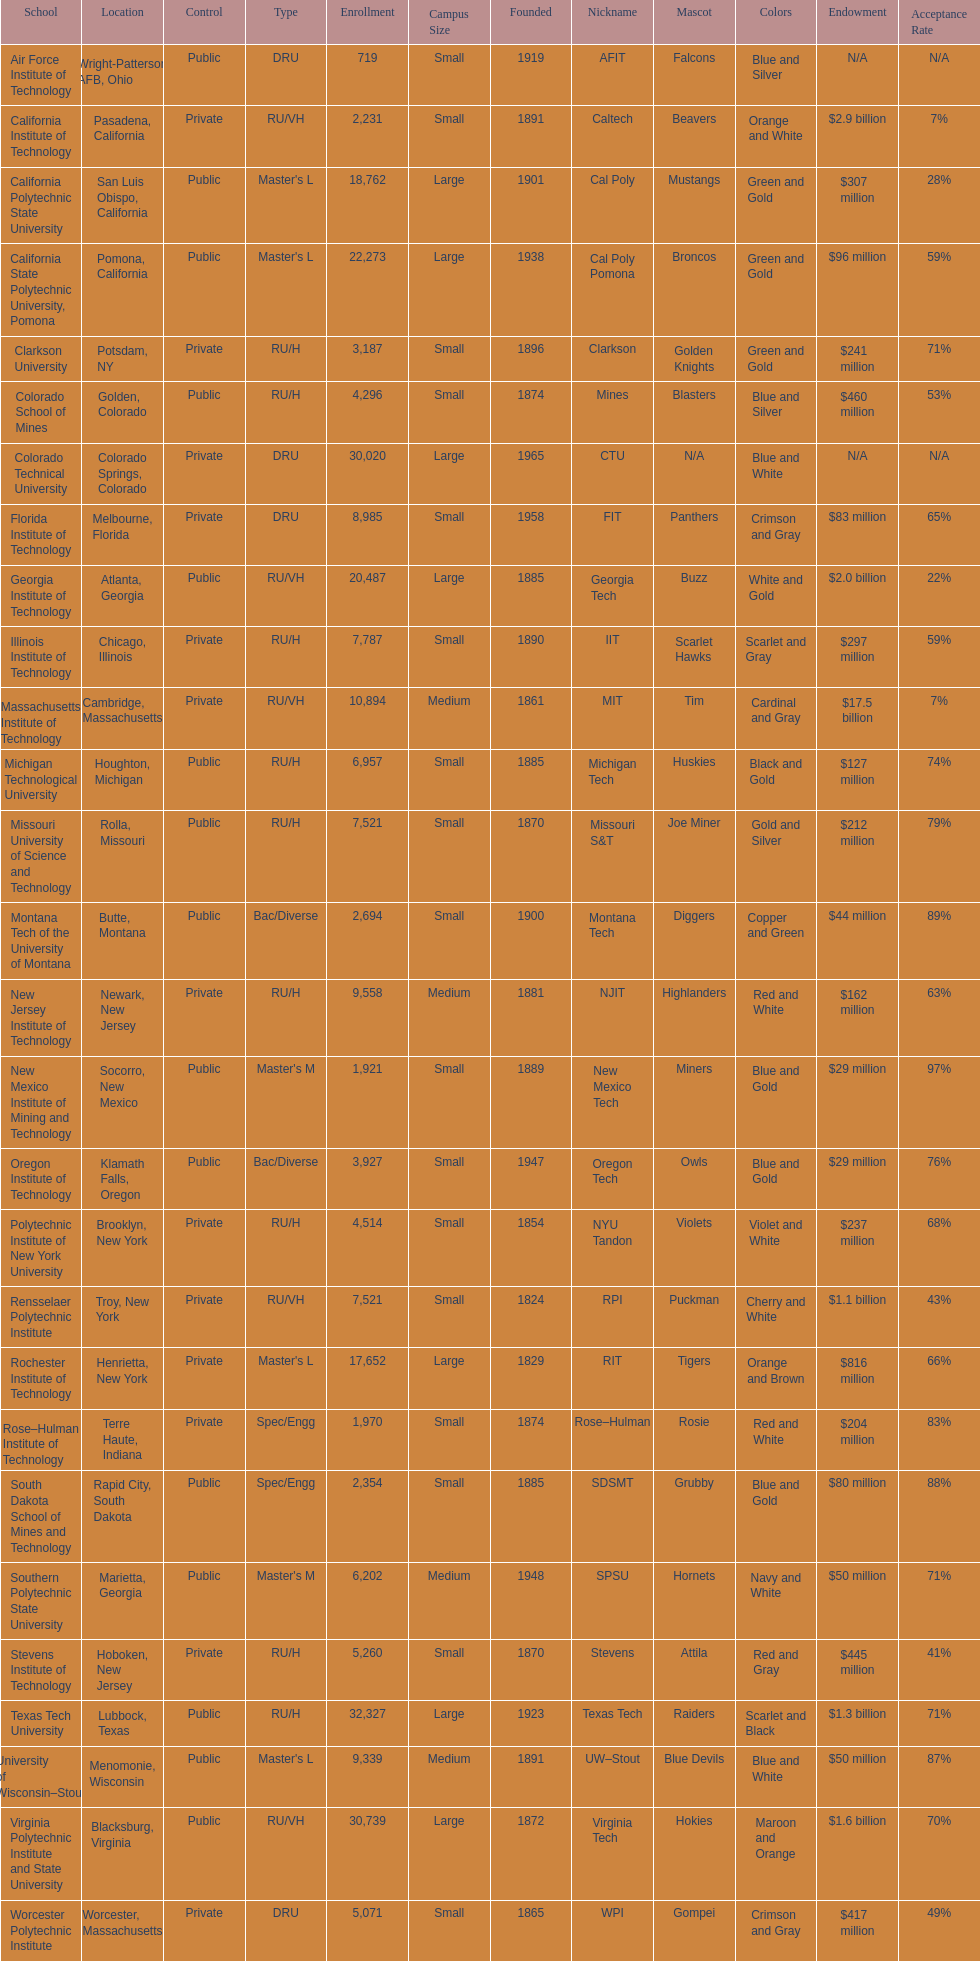Parse the full table. {'header': ['School', 'Location', 'Control', 'Type', 'Enrollment', 'Campus Size', 'Founded', 'Nickname', 'Mascot', 'Colors', 'Endowment', 'Acceptance Rate'], 'rows': [['Air Force Institute of Technology', 'Wright-Patterson AFB, Ohio', 'Public', 'DRU', '719', 'Small', '1919', 'AFIT', 'Falcons', 'Blue and Silver', 'N/A', 'N/A'], ['California Institute of Technology', 'Pasadena, California', 'Private', 'RU/VH', '2,231', 'Small', '1891', 'Caltech', 'Beavers', 'Orange and White', '$2.9 billion', '7%'], ['California Polytechnic State University', 'San Luis Obispo, California', 'Public', "Master's L", '18,762', 'Large', '1901', 'Cal Poly', 'Mustangs', 'Green and Gold', '$307 million', '28%'], ['California State Polytechnic University, Pomona', 'Pomona, California', 'Public', "Master's L", '22,273', 'Large', '1938', 'Cal Poly Pomona', 'Broncos', 'Green and Gold', '$96 million', '59%'], ['Clarkson University', 'Potsdam, NY', 'Private', 'RU/H', '3,187', 'Small', '1896', 'Clarkson', 'Golden Knights', 'Green and Gold', '$241 million', '71%'], ['Colorado School of Mines', 'Golden, Colorado', 'Public', 'RU/H', '4,296', 'Small', '1874', 'Mines', 'Blasters', 'Blue and Silver', '$460 million', '53%'], ['Colorado Technical University', 'Colorado Springs, Colorado', 'Private', 'DRU', '30,020', 'Large', '1965', 'CTU', 'N/A', 'Blue and White', 'N/A', 'N/A'], ['Florida Institute of Technology', 'Melbourne, Florida', 'Private', 'DRU', '8,985', 'Small', '1958', 'FIT', 'Panthers', 'Crimson and Gray', '$83 million', '65%'], ['Georgia Institute of Technology', 'Atlanta, Georgia', 'Public', 'RU/VH', '20,487', 'Large', '1885', 'Georgia Tech', 'Buzz', 'White and Gold', '$2.0 billion', '22%'], ['Illinois Institute of Technology', 'Chicago, Illinois', 'Private', 'RU/H', '7,787', 'Small', '1890', 'IIT', 'Scarlet Hawks', 'Scarlet and Gray', '$297 million', '59%'], ['Massachusetts Institute of Technology', 'Cambridge, Massachusetts', 'Private', 'RU/VH', '10,894', 'Medium', '1861', 'MIT', 'Tim', 'Cardinal and Gray', '$17.5 billion', '7%'], ['Michigan Technological University', 'Houghton, Michigan', 'Public', 'RU/H', '6,957', 'Small', '1885', 'Michigan Tech', 'Huskies', 'Black and Gold', '$127 million', '74%'], ['Missouri University of Science and Technology', 'Rolla, Missouri', 'Public', 'RU/H', '7,521', 'Small', '1870', 'Missouri S&T', 'Joe Miner', 'Gold and Silver', '$212 million', '79%'], ['Montana Tech of the University of Montana', 'Butte, Montana', 'Public', 'Bac/Diverse', '2,694', 'Small', '1900', 'Montana Tech', 'Diggers', 'Copper and Green', '$44 million', '89%'], ['New Jersey Institute of Technology', 'Newark, New Jersey', 'Private', 'RU/H', '9,558', 'Medium', '1881', 'NJIT', 'Highlanders', 'Red and White', '$162 million', '63%'], ['New Mexico Institute of Mining and Technology', 'Socorro, New Mexico', 'Public', "Master's M", '1,921', 'Small', '1889', 'New Mexico Tech', 'Miners', 'Blue and Gold', '$29 million', '97%'], ['Oregon Institute of Technology', 'Klamath Falls, Oregon', 'Public', 'Bac/Diverse', '3,927', 'Small', '1947', 'Oregon Tech', 'Owls', 'Blue and Gold', '$29 million', '76%'], ['Polytechnic Institute of New York University', 'Brooklyn, New York', 'Private', 'RU/H', '4,514', 'Small', '1854', 'NYU Tandon', 'Violets', 'Violet and White', '$237 million', '68%'], ['Rensselaer Polytechnic Institute', 'Troy, New York', 'Private', 'RU/VH', '7,521', 'Small', '1824', 'RPI', 'Puckman', 'Cherry and White', '$1.1 billion', '43%'], ['Rochester Institute of Technology', 'Henrietta, New York', 'Private', "Master's L", '17,652', 'Large', '1829', 'RIT', 'Tigers', 'Orange and Brown', '$816 million', '66%'], ['Rose–Hulman Institute of Technology', 'Terre Haute, Indiana', 'Private', 'Spec/Engg', '1,970', 'Small', '1874', 'Rose–Hulman', 'Rosie', 'Red and White', '$204 million', '83%'], ['South Dakota School of Mines and Technology', 'Rapid City, South Dakota', 'Public', 'Spec/Engg', '2,354', 'Small', '1885', 'SDSMT', 'Grubby', 'Blue and Gold', '$80 million', '88%'], ['Southern Polytechnic State University', 'Marietta, Georgia', 'Public', "Master's M", '6,202', 'Medium', '1948', 'SPSU', 'Hornets', 'Navy and White', '$50 million', '71%'], ['Stevens Institute of Technology', 'Hoboken, New Jersey', 'Private', 'RU/H', '5,260', 'Small', '1870', 'Stevens', 'Attila', 'Red and Gray', '$445 million', '41%'], ['Texas Tech University', 'Lubbock, Texas', 'Public', 'RU/H', '32,327', 'Large', '1923', 'Texas Tech', 'Raiders', 'Scarlet and Black', '$1.3 billion', '71%'], ['University of Wisconsin–Stout', 'Menomonie, Wisconsin', 'Public', "Master's L", '9,339', 'Medium', '1891', 'UW–Stout', 'Blue Devils', 'Blue and White', '$50 million', '87%'], ['Virginia Polytechnic Institute and State University', 'Blacksburg, Virginia', 'Public', 'RU/VH', '30,739', 'Large', '1872', 'Virginia Tech', 'Hokies', 'Maroon and Orange', '$1.6 billion', '70%'], ['Worcester Polytechnic Institute', 'Worcester, Massachusetts', 'Private', 'DRU', '5,071', 'Small', '1865', 'WPI', 'Gompei', 'Crimson and Gray', '$417 million', '49%']]} How many of the educational institutions were situated in california? 3. 